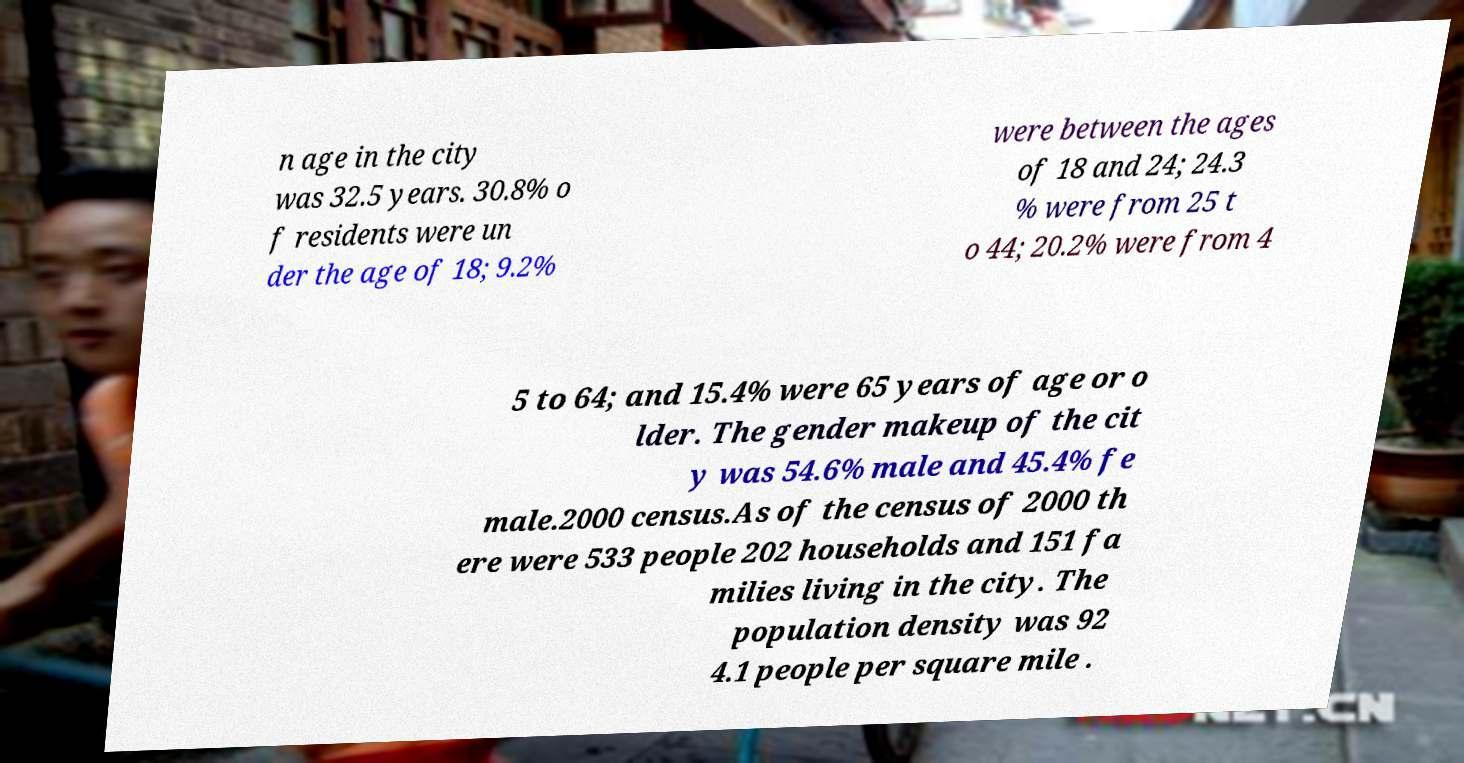What messages or text are displayed in this image? I need them in a readable, typed format. n age in the city was 32.5 years. 30.8% o f residents were un der the age of 18; 9.2% were between the ages of 18 and 24; 24.3 % were from 25 t o 44; 20.2% were from 4 5 to 64; and 15.4% were 65 years of age or o lder. The gender makeup of the cit y was 54.6% male and 45.4% fe male.2000 census.As of the census of 2000 th ere were 533 people 202 households and 151 fa milies living in the city. The population density was 92 4.1 people per square mile . 